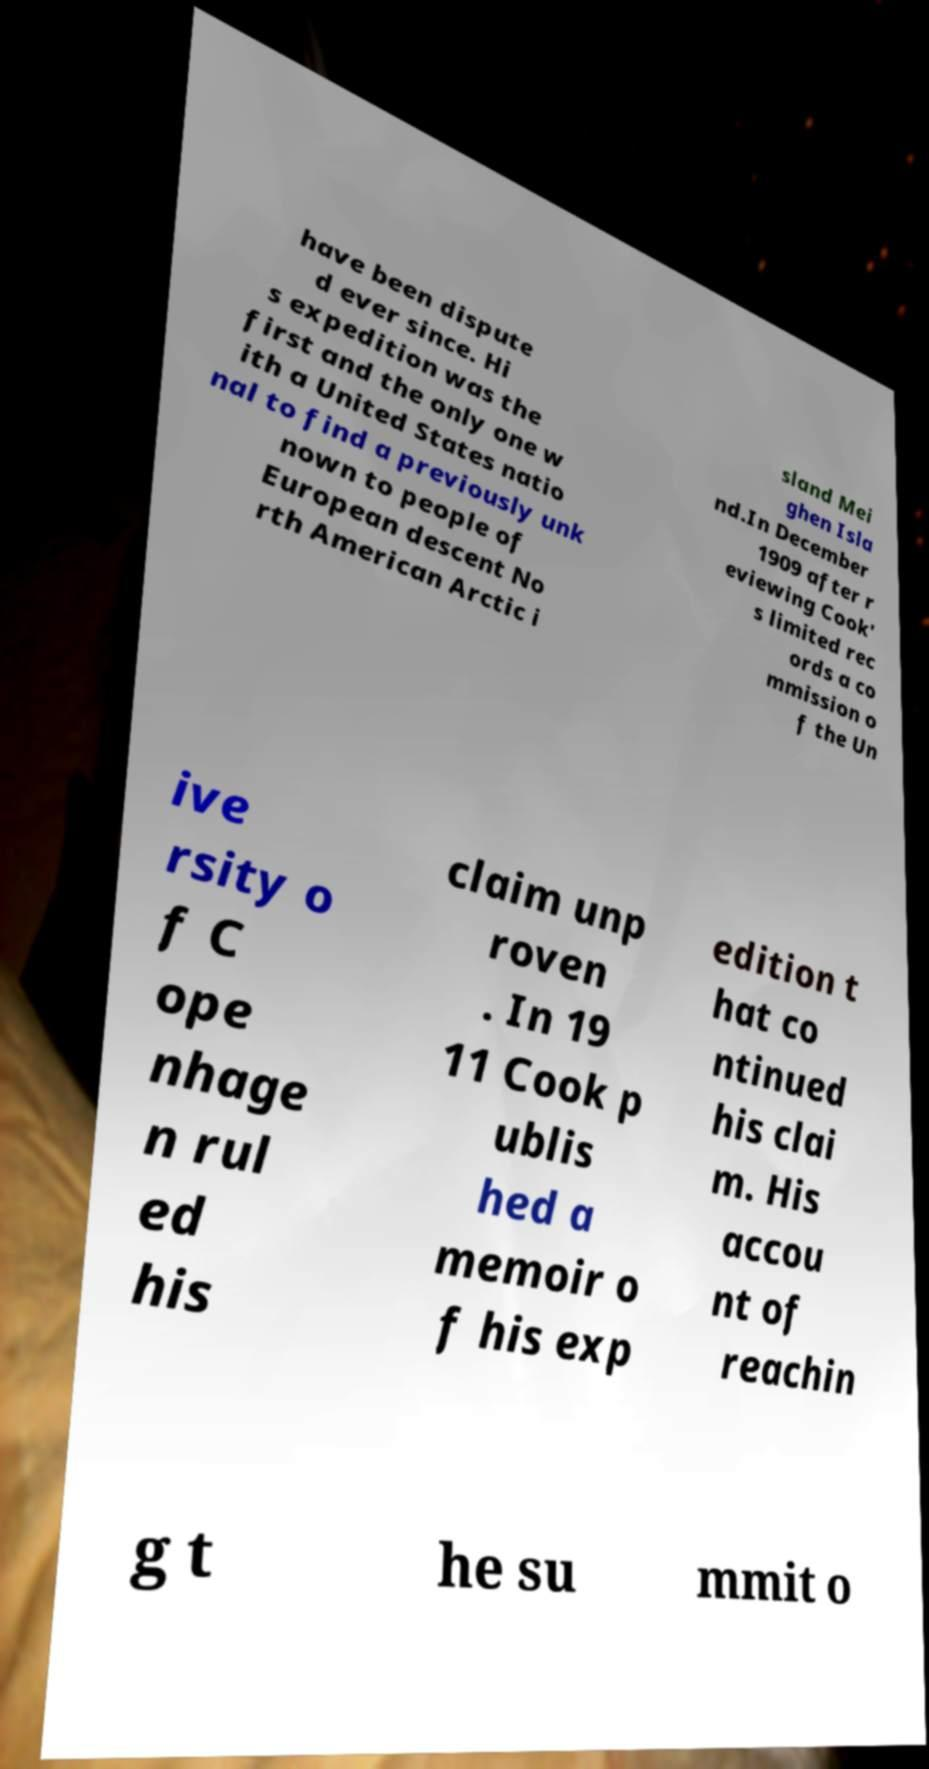What messages or text are displayed in this image? I need them in a readable, typed format. have been dispute d ever since. Hi s expedition was the first and the only one w ith a United States natio nal to find a previously unk nown to people of European descent No rth American Arctic i sland Mei ghen Isla nd.In December 1909 after r eviewing Cook' s limited rec ords a co mmission o f the Un ive rsity o f C ope nhage n rul ed his claim unp roven . In 19 11 Cook p ublis hed a memoir o f his exp edition t hat co ntinued his clai m. His accou nt of reachin g t he su mmit o 